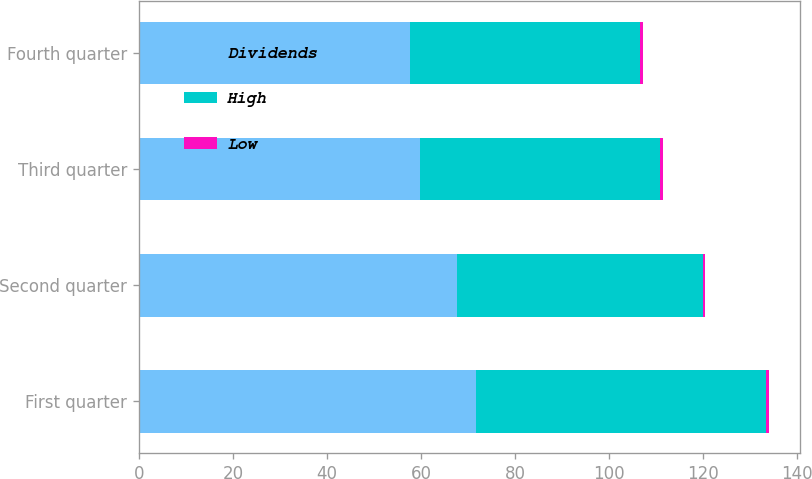Convert chart to OTSL. <chart><loc_0><loc_0><loc_500><loc_500><stacked_bar_chart><ecel><fcel>First quarter<fcel>Second quarter<fcel>Third quarter<fcel>Fourth quarter<nl><fcel>Dividends<fcel>71.62<fcel>67.58<fcel>59.89<fcel>57.69<nl><fcel>High<fcel>61.86<fcel>52.37<fcel>51.05<fcel>48.92<nl><fcel>Low<fcel>0.53<fcel>0.53<fcel>0.57<fcel>0.57<nl></chart> 